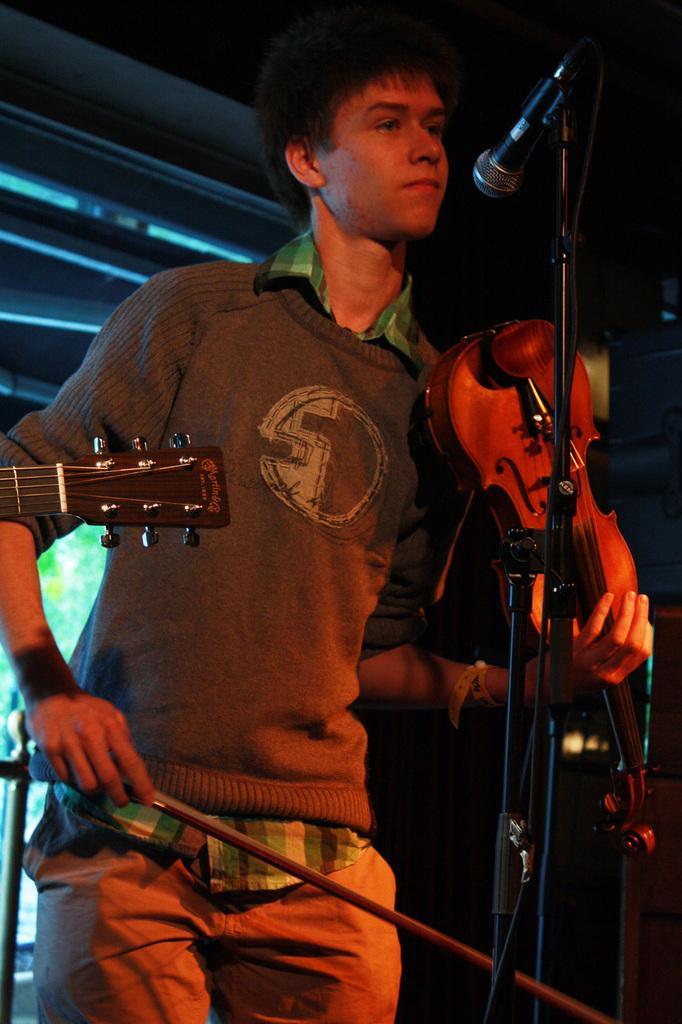Please provide a concise description of this image. In the image in the center we can see one person standing and holding violin. In front of him,there is a microphone. On the left side,we can see one guitar. In the background there is a wall,roof and few other objects. 